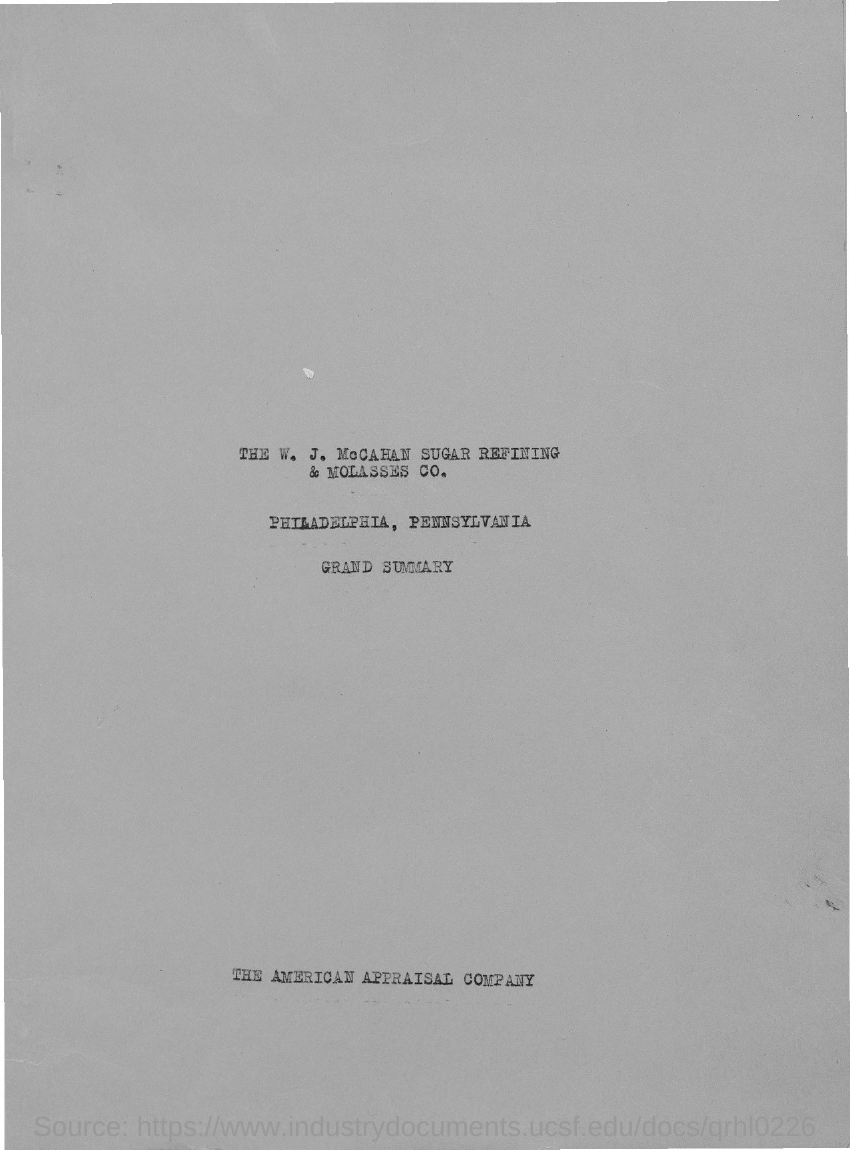Indicate a few pertinent items in this graphic. The title at the end of the document is "The American Appraisal Company. 